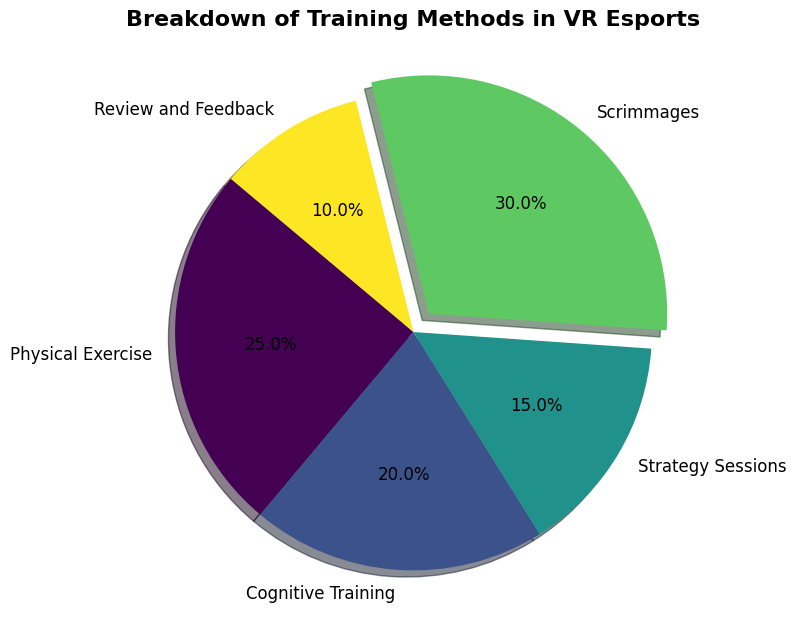What percentage of training methods is dedicated to both Physical Exercise and Scrimmages combined? To find the total percentage dedicated to Physical Exercise and Scrimmages, add their respective percentages: 25% for Physical Exercise and 30% for Scrimmages. 25% + 30% = 55%
Answer: 55% Which training method has the highest percentage allocation? The slice with the largest percentage in the pie chart is Scrimmages, which is visually indicated by the larger section and an exploded slice effect to emphasize it.
Answer: Scrimmages What is the difference in percentage allocation between Strategy Sessions and Review and Feedback? To find the difference in percentage allocation, subtract the smaller percentage (Review and Feedback) from the larger percentage (Strategy Sessions): 15% - 10% = 5%
Answer: 5% Which training method is the third largest in terms of percentage allocation? The sizes of the pie slices indicate the third largest training method, which is Physical Exercise (25%), followed by Scrimmages (30%) and Cognitive Training (20%).
Answer: Physical Exercise If we group Strategy Sessions and Review and Feedback, what percentage of the total training methods would this group represent? Add the percentages of Strategy Sessions and Review and Feedback: 15% (Strategy Sessions) + 10% (Review and Feedback) = 25%
Answer: 25% What color is used to represent Cognitive Training in the pie chart? Each category is assigned a unique color in the chart. Cognitive Training is represented by a greenish color as indicated in the visual.
Answer: Greenish By how much does the percentage allocated to Scrimmages exceed the percentage allocated to Cognitive Training? Subtract the percentage of Cognitive Training from the percentage of Scrimmages: 30% (Scrimmages) - 20% (Cognitive Training) = 10%
Answer: 10% What is the total percentage allocation of non-physical training methods? Add the percentages of all training methods except Physical Exercise: 20% (Cognitive Training) + 15% (Strategy Sessions) + 30% (Scrimmages) + 10% (Review and Feedback) = 75%
Answer: 75% Which training method is allocated the least percentage of time? The slice with the smallest percentage allocation in the pie chart is Review and Feedback, shown as the smallest segment.
Answer: Review and Feedback 